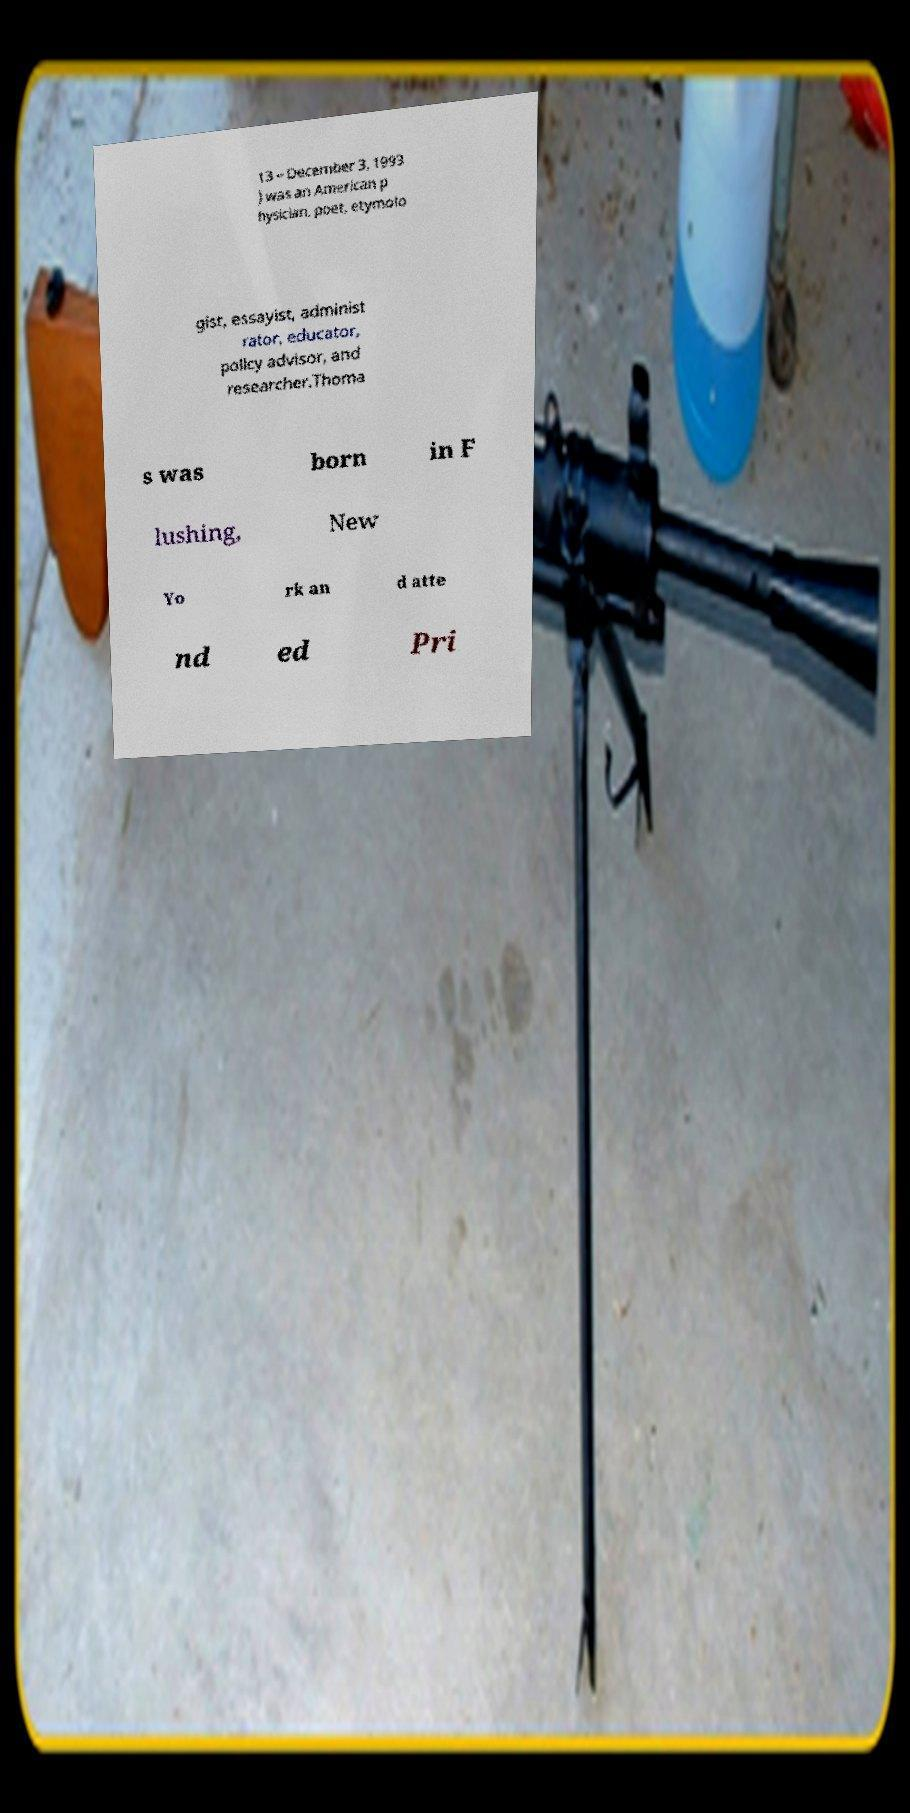I need the written content from this picture converted into text. Can you do that? 13 – December 3, 1993 ) was an American p hysician, poet, etymolo gist, essayist, administ rator, educator, policy advisor, and researcher.Thoma s was born in F lushing, New Yo rk an d atte nd ed Pri 